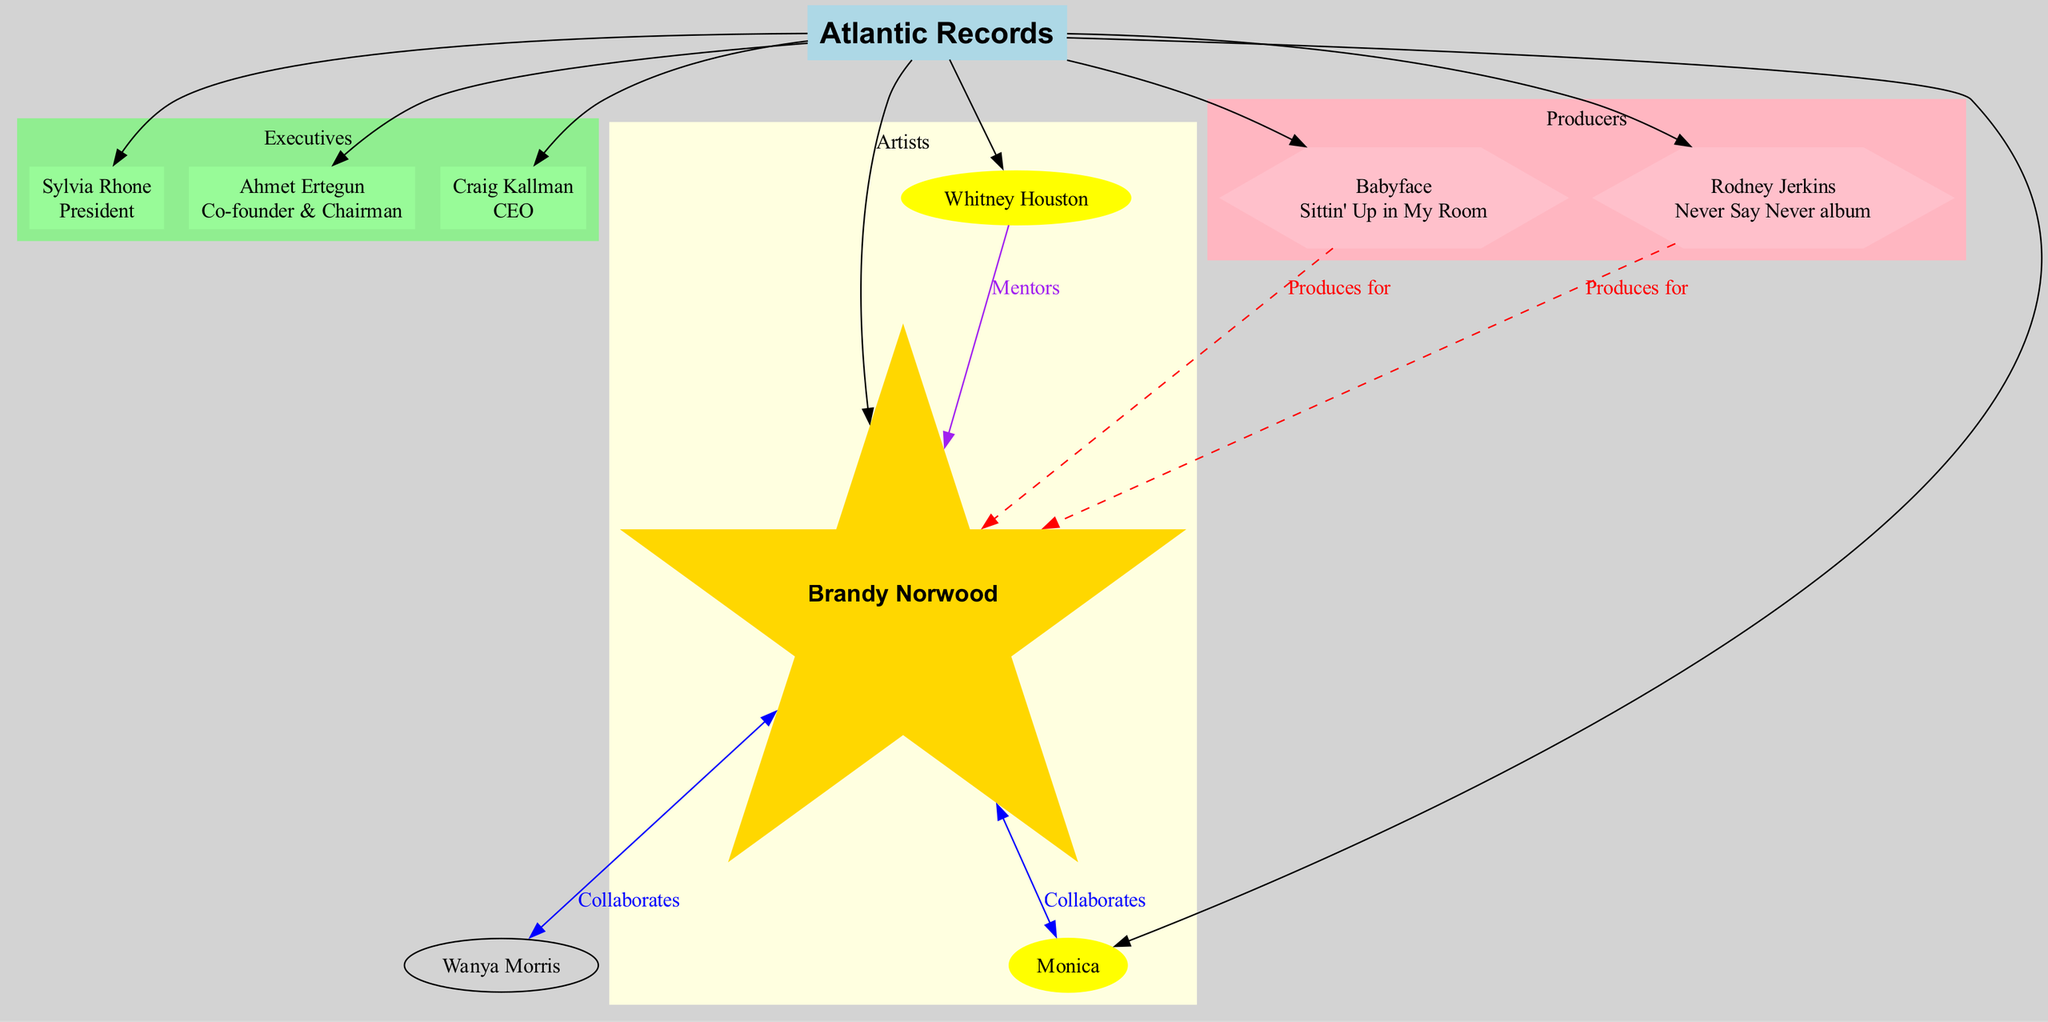What is the role of Craig Kallman? Craig Kallman is listed as the CEO of Atlantic Records in the diagram. This information is directly presented next to his name within the executives cluster.
Answer: CEO Who is Brandy's mentor? Brandy Norwood's mentor is Whitney Houston, as indicated by the mentorship relationship labeled in the diagram.
Answer: Whitney Houston How many producers are associated with Brandy? The diagram shows two producers associated with Brandy: Rodney Jerkins and Babyface. Therefore, the count is two.
Answer: 2 Which artist collaborated with Brandy? The artist who collaborated with Brandy, as indicated in the diagram, is Monica. This relationship is represented clearly with a bidirectional edge.
Answer: Monica Who is the president of Atlantic Records? Sylvia Rhone is listed as the President of Atlantic Records in the executives section of the diagram.
Answer: Sylvia Rhone What type of edge connects Whitney Houston to Brandy Norwood? The edge connecting Whitney Houston to Brandy Norwood is labeled 'Mentors', indicating a mentorship relationship. This is specifically mentioned in the diagram.
Answer: Mentors Name one work associated with Rodney Jerkins. The diagram states that Rodney Jerkins worked on the 'Never Say Never album.' This information is noted next to his name in the producers cluster.
Answer: Never Say Never album How many artists are depicted in the diagram? The diagram shows three distinct artists: Brandy Norwood, Whitney Houston, and Monica. Therefore, the total number of artists is three.
Answer: 3 What color represents the executives' cluster? The executives' cluster in the diagram is represented with a light green color coding. This visual aspect is specified under the cluster settings.
Answer: light green 